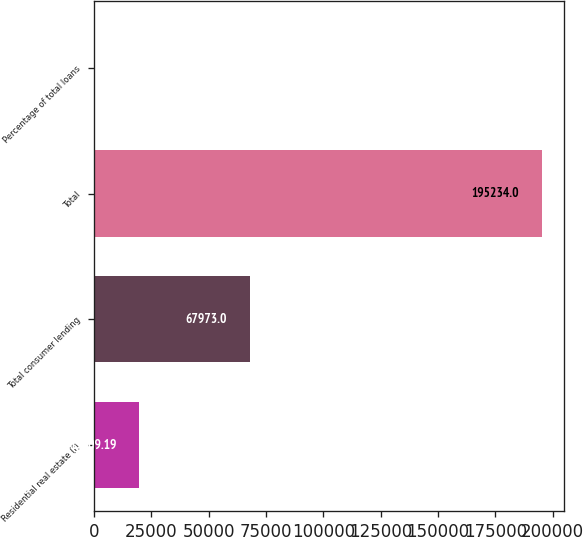<chart> <loc_0><loc_0><loc_500><loc_500><bar_chart><fcel>Residential real estate (f)<fcel>Total consumer lending<fcel>Total<fcel>Percentage of total loans<nl><fcel>19609.2<fcel>67973<fcel>195234<fcel>95.32<nl></chart> 